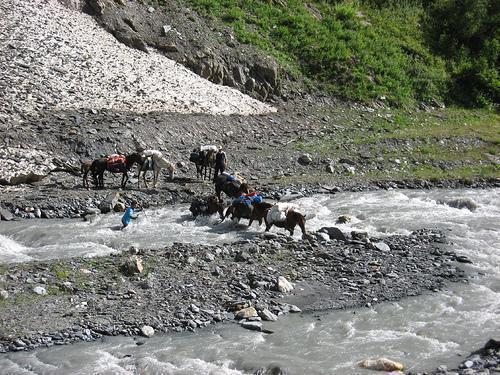Where are these animals located?
Choose the correct response and explain in the format: 'Answer: answer
Rationale: rationale.'
Options: Mountains, beach, desert, arctic. Answer: mountains.
Rationale: The animals are in the mountains. 